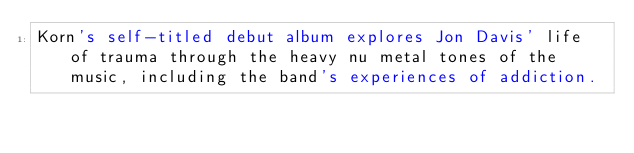<code> <loc_0><loc_0><loc_500><loc_500><_HTML_>Korn's self-titled debut album explores Jon Davis' life of trauma through the heavy nu metal tones of the music, including the band's experiences of addiction.</code> 